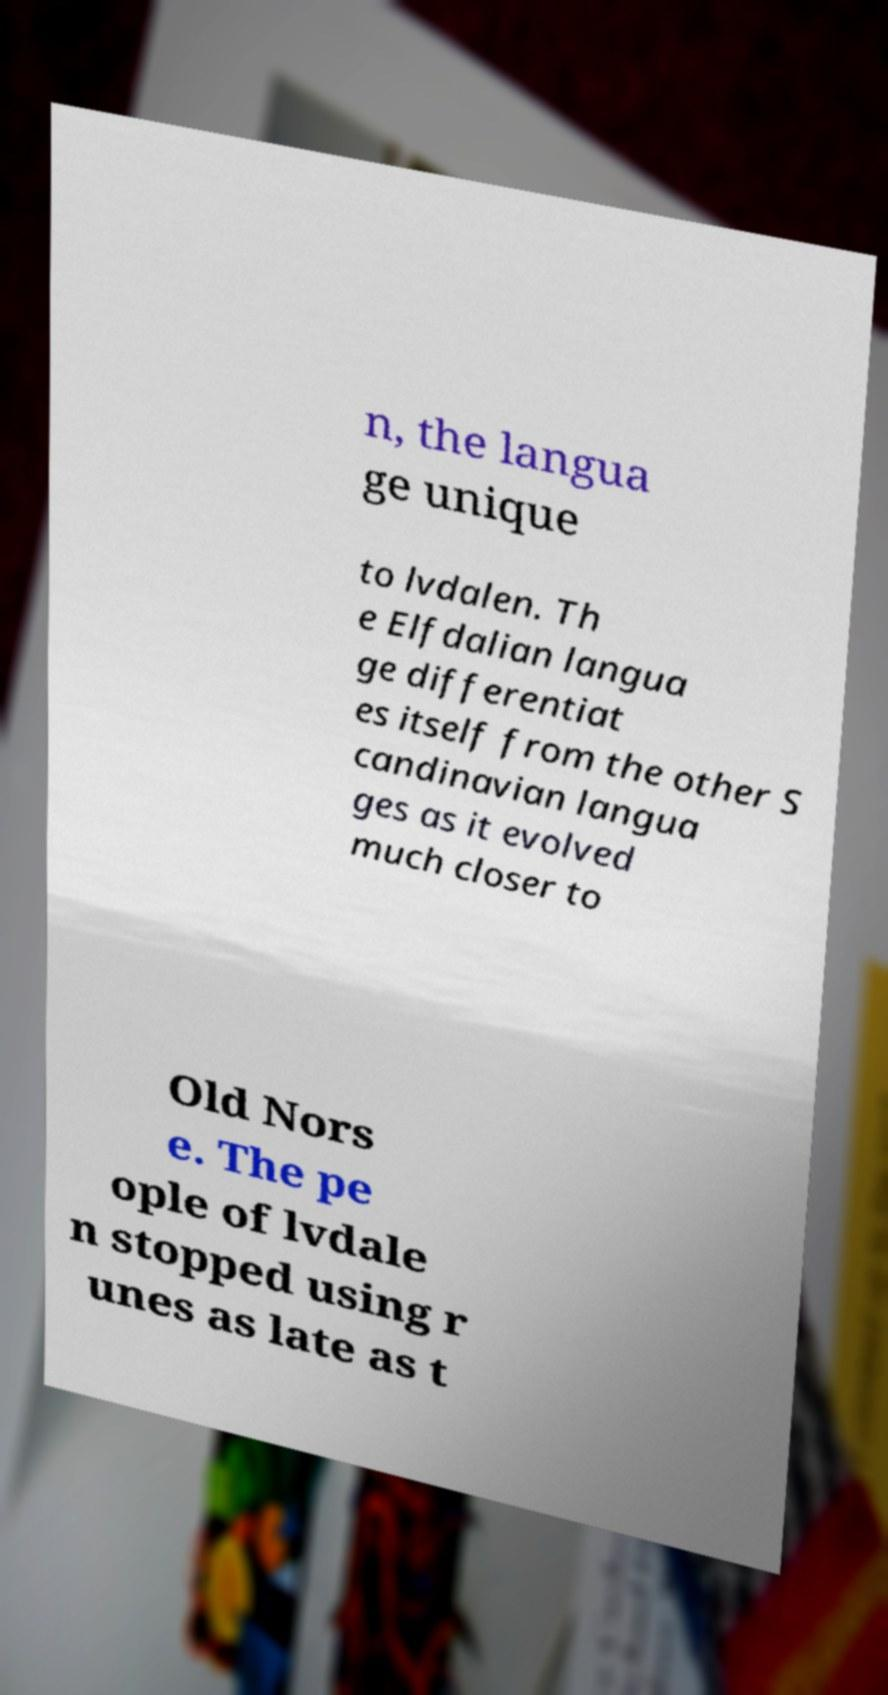Could you extract and type out the text from this image? n, the langua ge unique to lvdalen. Th e Elfdalian langua ge differentiat es itself from the other S candinavian langua ges as it evolved much closer to Old Nors e. The pe ople of lvdale n stopped using r unes as late as t 